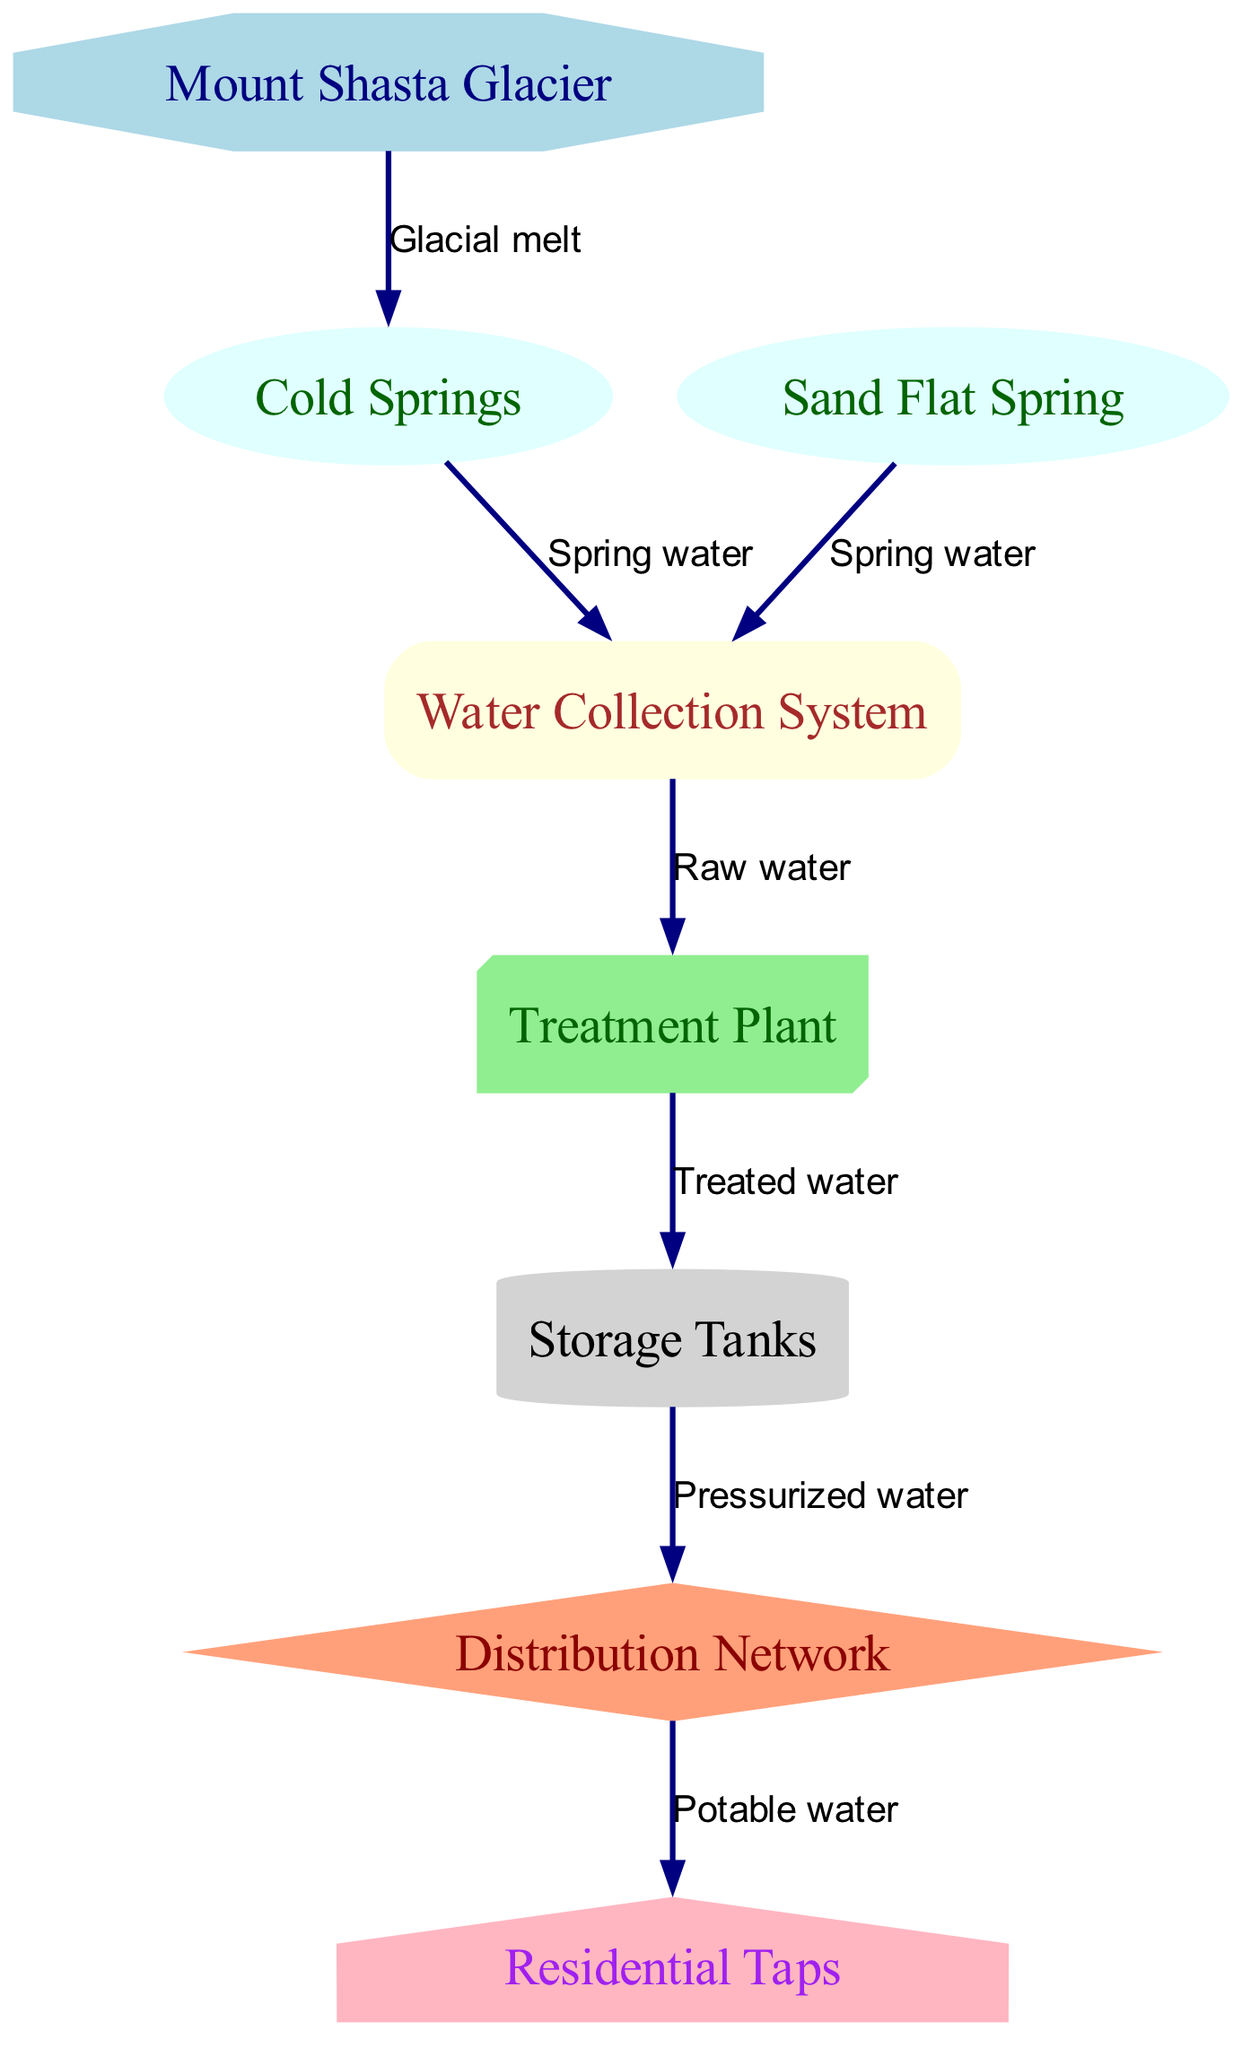What is the source of water in the system? The diagram indicates that the water originates from the "Mount Shasta Glacier," which is the first node in the network.
Answer: Mount Shasta Glacier How many nodes are present in the diagram? By counting all the nodes listed in the data, there are eight different nodes representing various components of the water supply system.
Answer: 8 What type of water flows from Cold Springs to the Water Collection System? The relationship between Cold Springs and the Water Collection System is labeled as "Spring water," indicating the type of water that flows in that direction.
Answer: Spring water Which node is directly connected to the Treatment Plant? Following the edges, the node that connects directly to the Treatment Plant is the Water Collection System based on the pathway outlined in the diagram.
Answer: Water Collection System What type of water is treated at the Treatment Plant before storage? The Treatment Plant processes "Raw water" as indicated by the label on the edge connecting it to the Water Collection System, which shows the type of water entering the plant.
Answer: Raw water What is the final destination of the distribution network? The last connection in the diagram indicates that the output from the Distribution Network reaches the Residential Taps, marking the endpoint of the water flow system.
Answer: Residential Taps What process takes place at the Treatment Plant? The diagram shows that the Treatment Plant transforms "Raw water" into "Treated water," indicating the process it performs to make the water suitable for storage.
Answer: Treated water How does water travel from Storage Tanks to Residential Taps? Water moves from the Storage Tanks to Residential Taps through the Distribution Network, with the label indicating that it is delivered as "Potable water."
Answer: Potable water What is the shape of the node representing Storage Tanks? According to the diagram's specifications, the Storage Tanks are represented as a "cylinder," which is a specific shape used for this node type in the illustration.
Answer: Cylinder 